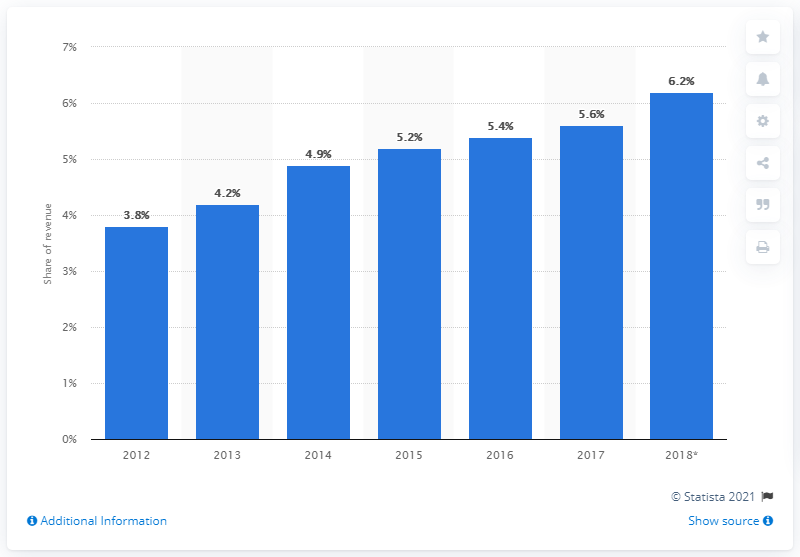Mention a couple of crucial points in this snapshot. In 2017, online TV advertising accounted for 5.6% of total TV advertising revenue. Online TV advertising is expected to account for approximately 6.2% of total TV advertising revenues in 2018. In 2018, online TV advertising is projected to make up approximately 6.2% of total TV advertising revenues. 